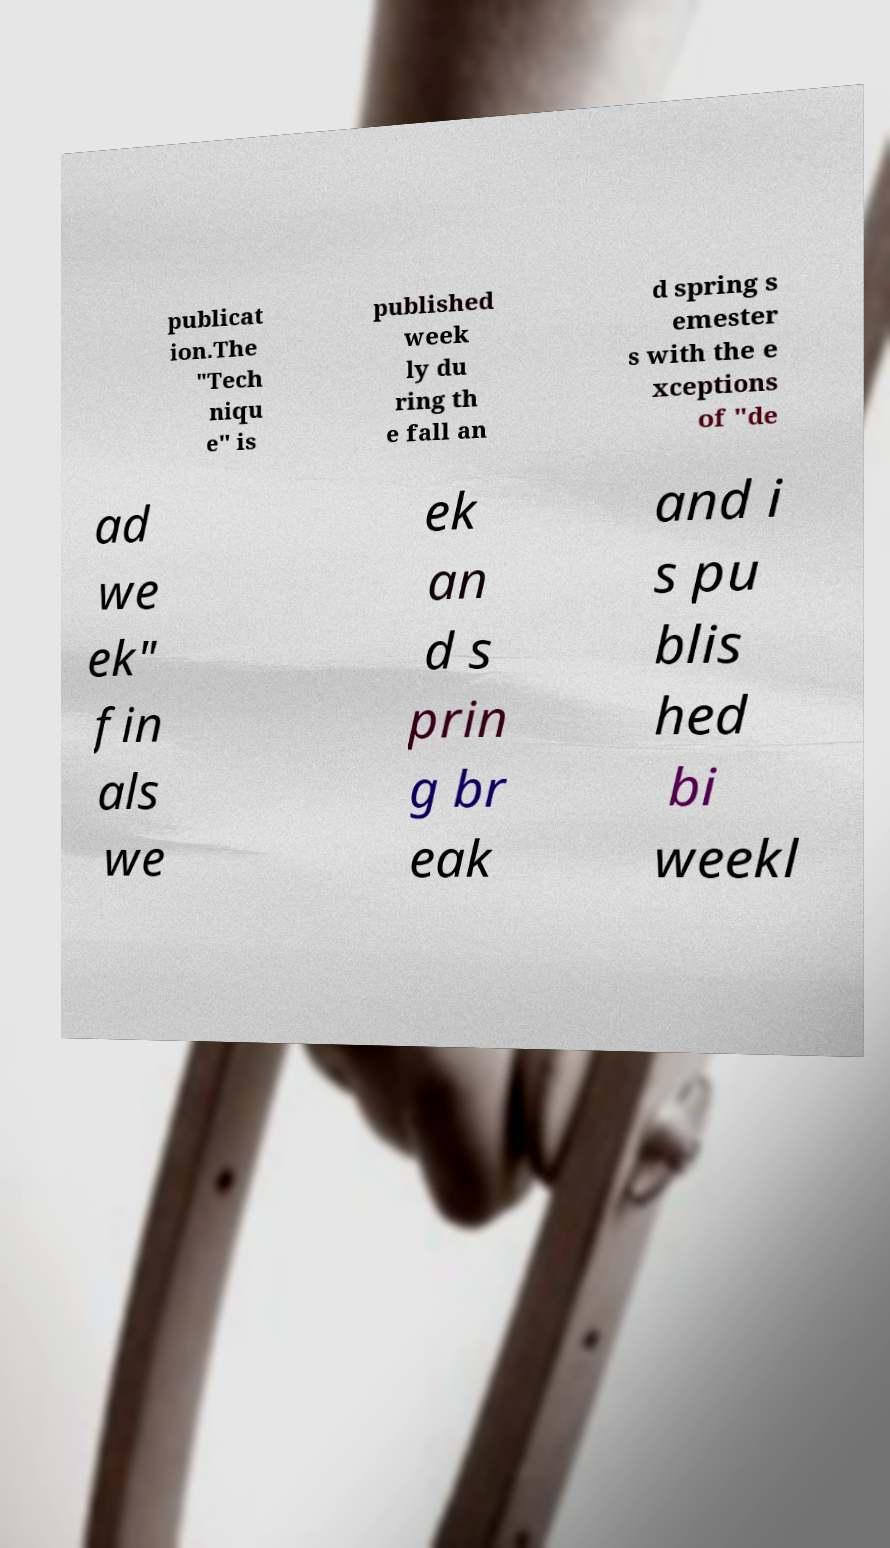Could you extract and type out the text from this image? publicat ion.The "Tech niqu e" is published week ly du ring th e fall an d spring s emester s with the e xceptions of "de ad we ek" fin als we ek an d s prin g br eak and i s pu blis hed bi weekl 